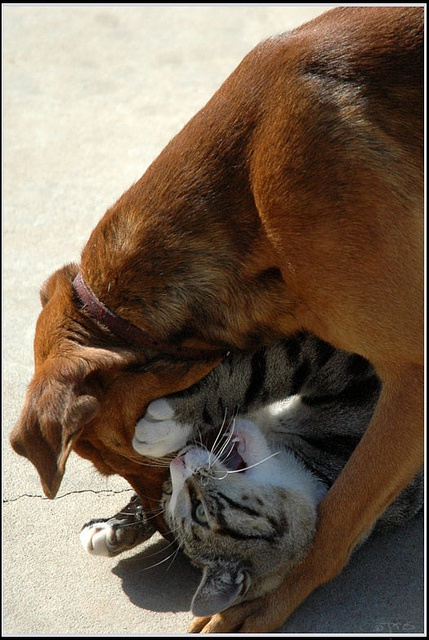Describe the objects in this image and their specific colors. I can see dog in black, maroon, and brown tones and cat in black, gray, and darkgray tones in this image. 